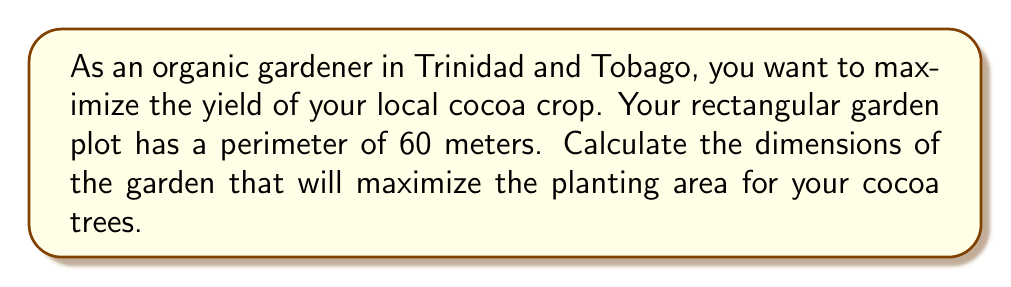Give your solution to this math problem. Let's approach this step-by-step using calculus optimization:

1) Let the width of the garden be $w$ and the length be $l$.

2) Given that the perimeter is 60 meters, we can write:
   $2w + 2l = 60$
   $l = 30 - w$

3) The area $A$ of the garden is given by:
   $A = w \cdot l = w(30-w) = 30w - w^2$

4) To find the maximum area, we need to find the critical points. Let's differentiate $A$ with respect to $w$:
   $$\frac{dA}{dw} = 30 - 2w$$

5) Set this equal to zero to find the critical point:
   $30 - 2w = 0$
   $w = 15$

6) The second derivative is:
   $$\frac{d^2A}{dw^2} = -2$$

   Since this is negative, the critical point is a maximum.

7) When $w = 15$, $l = 30 - 15 = 15$

Therefore, the garden should be a square with sides of 15 meters each to maximize the planting area.

8) The maximum area is:
   $A = 15 \cdot 15 = 225$ square meters

[asy]
unitsize(4mm);
draw((0,0)--(15,0)--(15,15)--(0,15)--cycle);
label("15 m", (7.5,0), S);
label("15 m", (0,7.5), W);
label("Cocoa Garden", (7.5,7.5));
[/asy]
Answer: The optimal dimensions for maximum planting area are 15 meters by 15 meters, creating a square garden with an area of 225 square meters. 